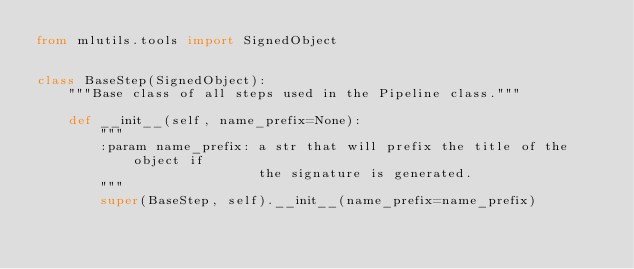Convert code to text. <code><loc_0><loc_0><loc_500><loc_500><_Python_>from mlutils.tools import SignedObject


class BaseStep(SignedObject):
    """Base class of all steps used in the Pipeline class."""

    def __init__(self, name_prefix=None):
        """
        :param name_prefix: a str that will prefix the title of the object if
                            the signature is generated.
        """
        super(BaseStep, self).__init__(name_prefix=name_prefix)
</code> 